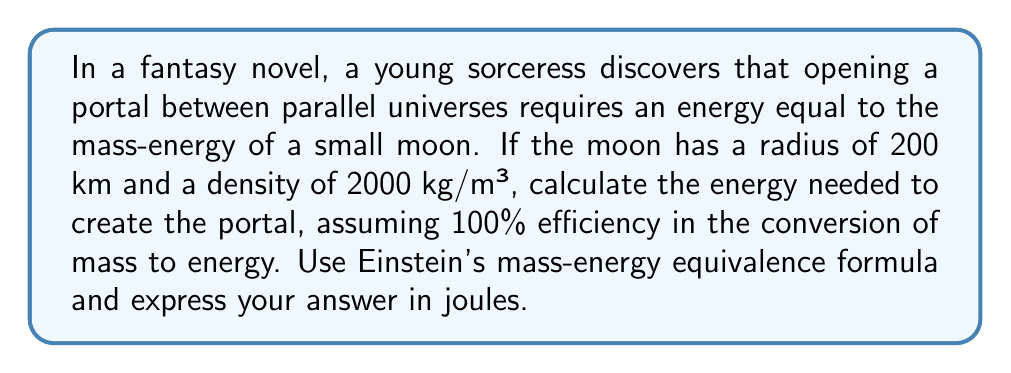Help me with this question. To solve this problem, we'll follow these steps:

1) First, calculate the volume of the moon:
   $$V = \frac{4}{3}\pi r^3$$
   $$V = \frac{4}{3}\pi (200,000 \text{ m})^3 = 3.35 \times 10^{16} \text{ m}^3$$

2) Calculate the mass of the moon using its density:
   $$m = \rho V$$
   $$m = (2000 \text{ kg/m}^3)(3.35 \times 10^{16} \text{ m}^3) = 6.70 \times 10^{19} \text{ kg}$$

3) Use Einstein's mass-energy equivalence formula to calculate the energy:
   $$E = mc^2$$
   Where $c$ is the speed of light (approximately $3 \times 10^8 \text{ m/s}$)

   $$E = (6.70 \times 10^{19} \text{ kg})(3 \times 10^8 \text{ m/s})^2$$
   $$E = 6.03 \times 10^{36} \text{ J}$$

Therefore, the energy required to open the portal between parallel universes is approximately $6.03 \times 10^{36}$ joules.
Answer: $6.03 \times 10^{36} \text{ J}$ 